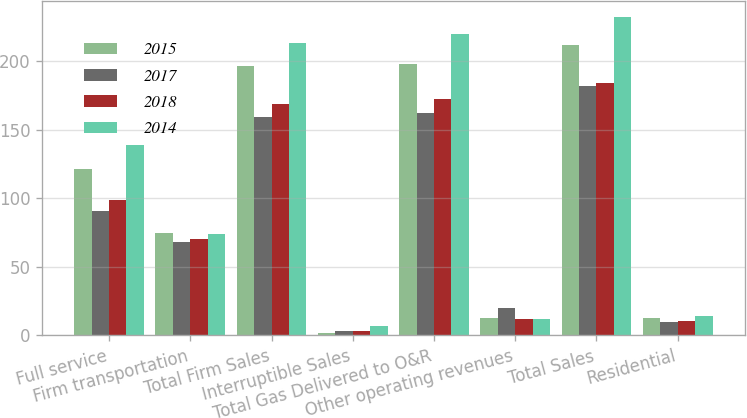<chart> <loc_0><loc_0><loc_500><loc_500><stacked_bar_chart><ecel><fcel>Full service<fcel>Firm transportation<fcel>Total Firm Sales<fcel>Interruptible Sales<fcel>Total Gas Delivered to O&R<fcel>Other operating revenues<fcel>Total Sales<fcel>Residential<nl><fcel>2015<fcel>121<fcel>75<fcel>196<fcel>2<fcel>198<fcel>13<fcel>212<fcel>13.01<nl><fcel>2017<fcel>91<fcel>68<fcel>159<fcel>3<fcel>162<fcel>20<fcel>182<fcel>10.11<nl><fcel>2018<fcel>99<fcel>70<fcel>169<fcel>3<fcel>172<fcel>12<fcel>184<fcel>10.71<nl><fcel>2014<fcel>139<fcel>74<fcel>213<fcel>7<fcel>220<fcel>12<fcel>232<fcel>13.86<nl></chart> 